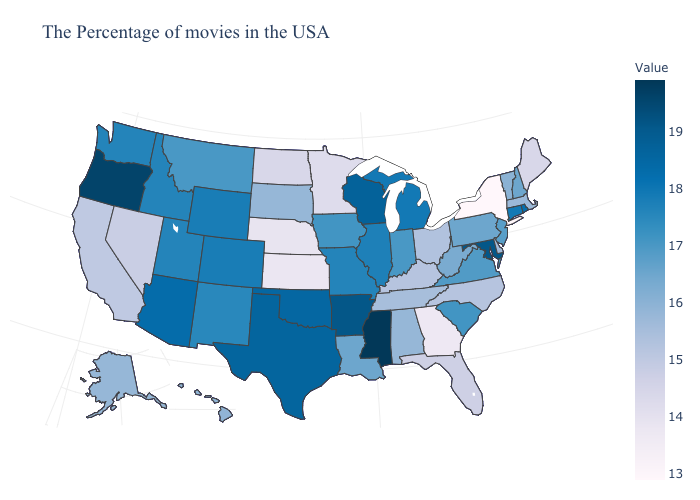Among the states that border Rhode Island , does Massachusetts have the lowest value?
Concise answer only. Yes. Among the states that border Kentucky , does Ohio have the lowest value?
Short answer required. Yes. Does the map have missing data?
Short answer required. No. Among the states that border Connecticut , does Rhode Island have the highest value?
Write a very short answer. Yes. Does New York have the lowest value in the USA?
Answer briefly. Yes. 